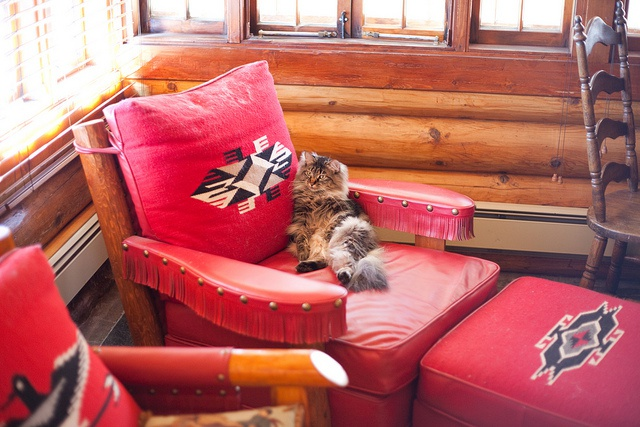Describe the objects in this image and their specific colors. I can see chair in lavender, brown, lightpink, and salmon tones, chair in lavender, brown, maroon, and salmon tones, chair in lavender, brown, purple, and black tones, and cat in lavender, brown, lightpink, and maroon tones in this image. 